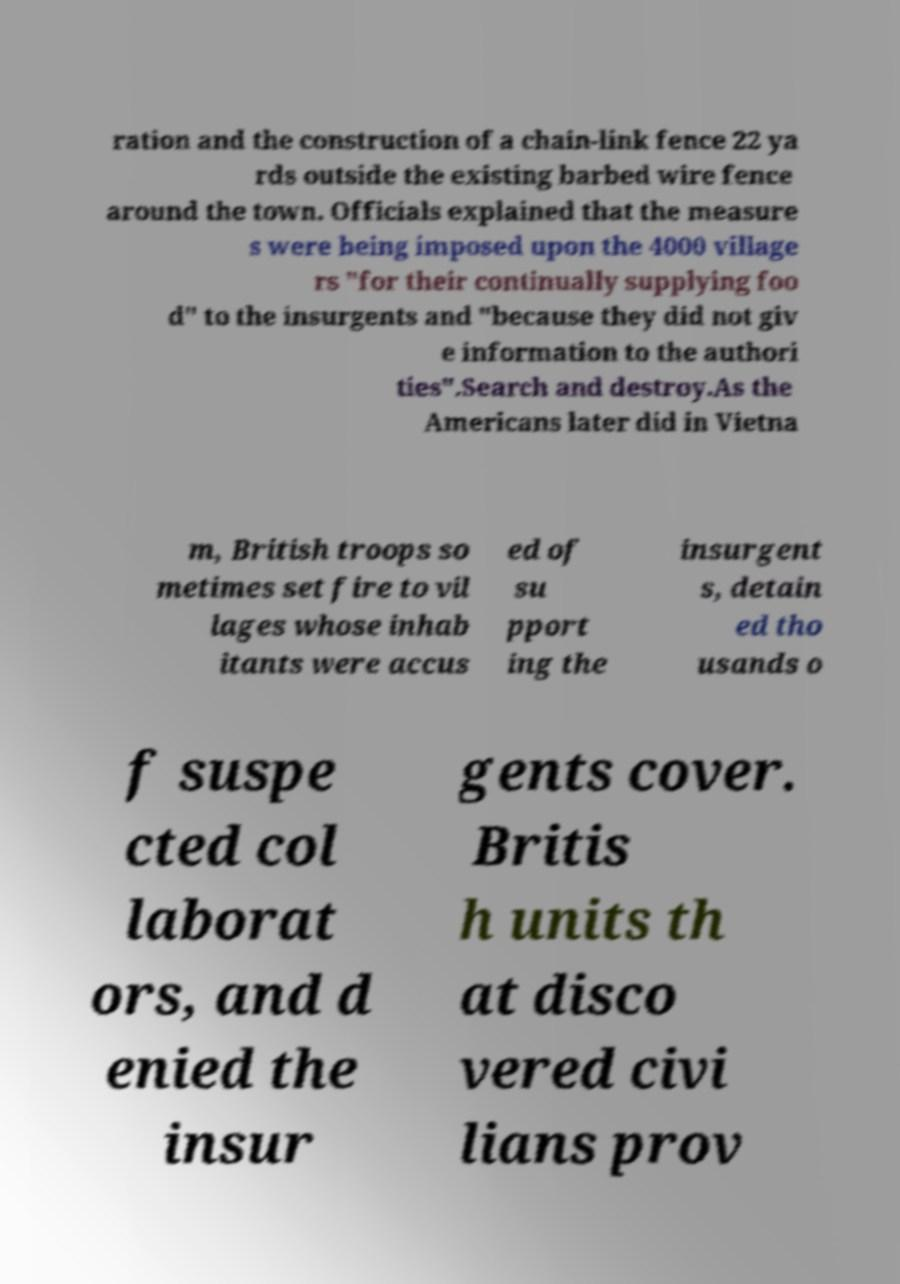For documentation purposes, I need the text within this image transcribed. Could you provide that? ration and the construction of a chain-link fence 22 ya rds outside the existing barbed wire fence around the town. Officials explained that the measure s were being imposed upon the 4000 village rs "for their continually supplying foo d" to the insurgents and "because they did not giv e information to the authori ties".Search and destroy.As the Americans later did in Vietna m, British troops so metimes set fire to vil lages whose inhab itants were accus ed of su pport ing the insurgent s, detain ed tho usands o f suspe cted col laborat ors, and d enied the insur gents cover. Britis h units th at disco vered civi lians prov 